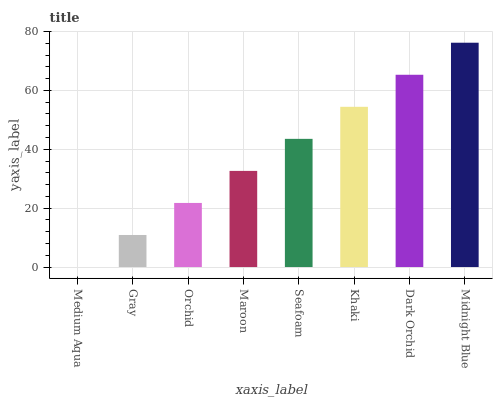Is Medium Aqua the minimum?
Answer yes or no. Yes. Is Midnight Blue the maximum?
Answer yes or no. Yes. Is Gray the minimum?
Answer yes or no. No. Is Gray the maximum?
Answer yes or no. No. Is Gray greater than Medium Aqua?
Answer yes or no. Yes. Is Medium Aqua less than Gray?
Answer yes or no. Yes. Is Medium Aqua greater than Gray?
Answer yes or no. No. Is Gray less than Medium Aqua?
Answer yes or no. No. Is Seafoam the high median?
Answer yes or no. Yes. Is Maroon the low median?
Answer yes or no. Yes. Is Orchid the high median?
Answer yes or no. No. Is Seafoam the low median?
Answer yes or no. No. 